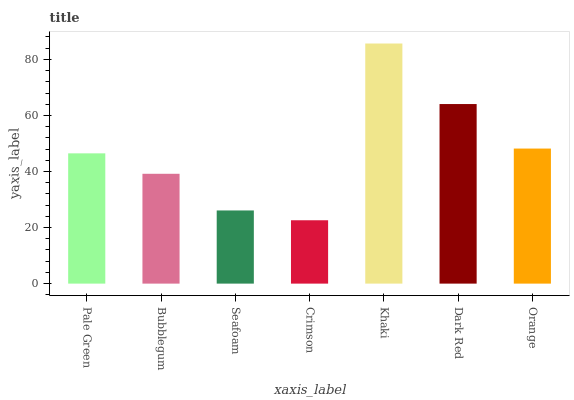Is Crimson the minimum?
Answer yes or no. Yes. Is Khaki the maximum?
Answer yes or no. Yes. Is Bubblegum the minimum?
Answer yes or no. No. Is Bubblegum the maximum?
Answer yes or no. No. Is Pale Green greater than Bubblegum?
Answer yes or no. Yes. Is Bubblegum less than Pale Green?
Answer yes or no. Yes. Is Bubblegum greater than Pale Green?
Answer yes or no. No. Is Pale Green less than Bubblegum?
Answer yes or no. No. Is Pale Green the high median?
Answer yes or no. Yes. Is Pale Green the low median?
Answer yes or no. Yes. Is Orange the high median?
Answer yes or no. No. Is Crimson the low median?
Answer yes or no. No. 